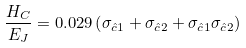<formula> <loc_0><loc_0><loc_500><loc_500>\frac { H _ { C } } { E _ { J } } = 0 . 0 2 9 \left ( \sigma _ { \hat { c } 1 } + \sigma _ { \hat { c } 2 } + \sigma _ { \hat { c } 1 } \sigma _ { \hat { c } 2 } \right )</formula> 